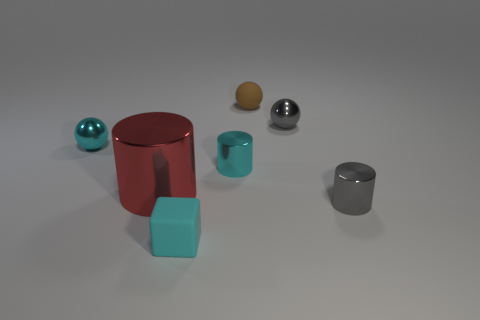Subtract all cyan cylinders. How many cylinders are left? 2 Add 1 cyan metallic things. How many objects exist? 8 Subtract all brown spheres. How many spheres are left? 2 Subtract all balls. How many objects are left? 4 Subtract 1 spheres. How many spheres are left? 2 Subtract all green cylinders. Subtract all yellow blocks. How many cylinders are left? 3 Subtract all small cyan things. Subtract all cyan spheres. How many objects are left? 3 Add 4 tiny gray balls. How many tiny gray balls are left? 5 Add 2 tiny cyan spheres. How many tiny cyan spheres exist? 3 Subtract 1 gray cylinders. How many objects are left? 6 